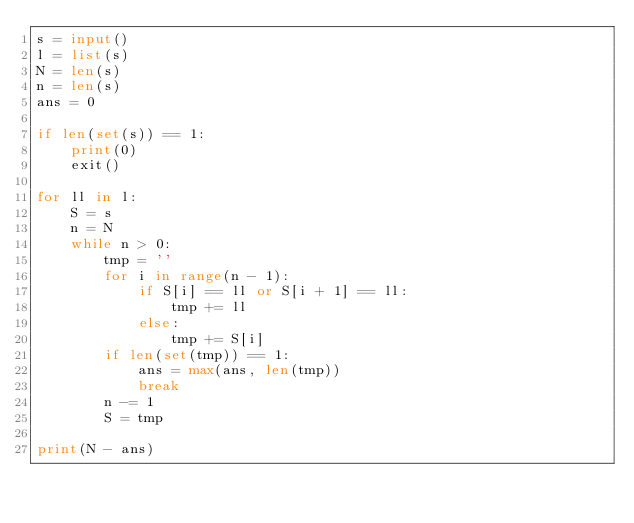Convert code to text. <code><loc_0><loc_0><loc_500><loc_500><_Python_>s = input()
l = list(s)
N = len(s)
n = len(s)
ans = 0

if len(set(s)) == 1:
    print(0)
    exit()

for ll in l:
    S = s
    n = N
    while n > 0:
        tmp = ''
        for i in range(n - 1):
            if S[i] == ll or S[i + 1] == ll:
                tmp += ll
            else:
                tmp += S[i]
        if len(set(tmp)) == 1:
            ans = max(ans, len(tmp))
            break
        n -= 1
        S = tmp

print(N - ans)
</code> 